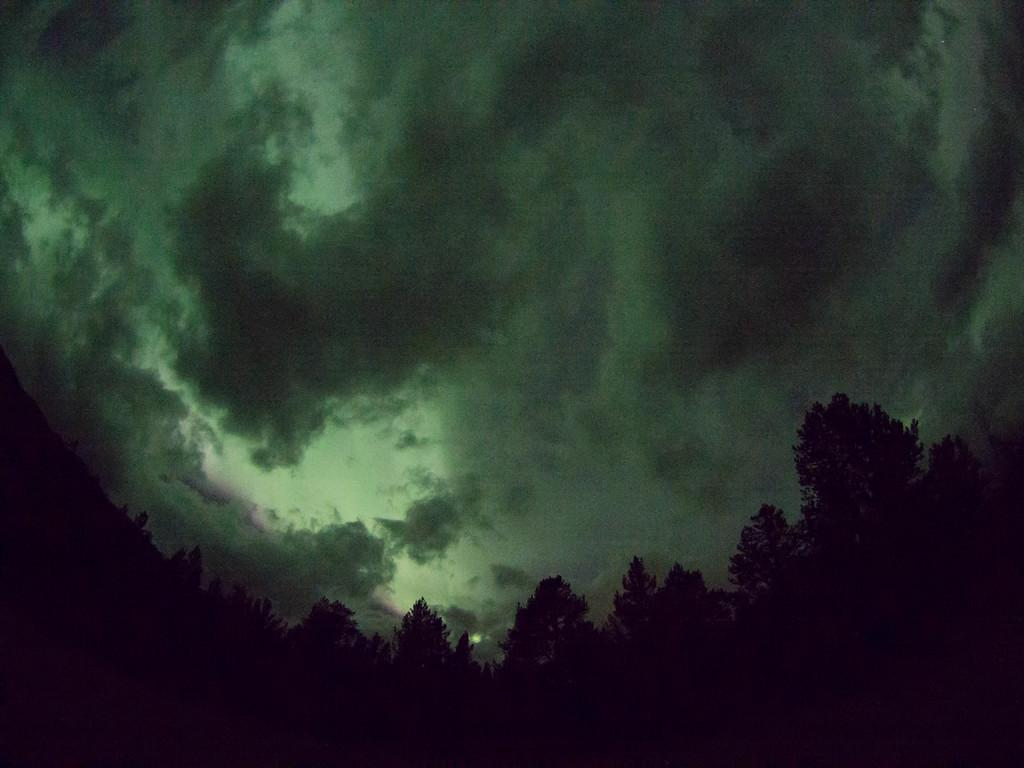What type of vegetation can be seen in the image? There are trees present in the image. How are the trees distributed in the image? The trees are spread throughout the image. What is visible in the background of the image? The sky is visible in the image. What is the condition of the sky in the image? The sky is fully covered with clouds. How many crackers are being held by the boys in the image? There are no boys or crackers present in the image. What type of tool is being used to clean the leaves in the image? There is no tool or leaves being cleaned in the image; it only features trees and a cloudy sky. 